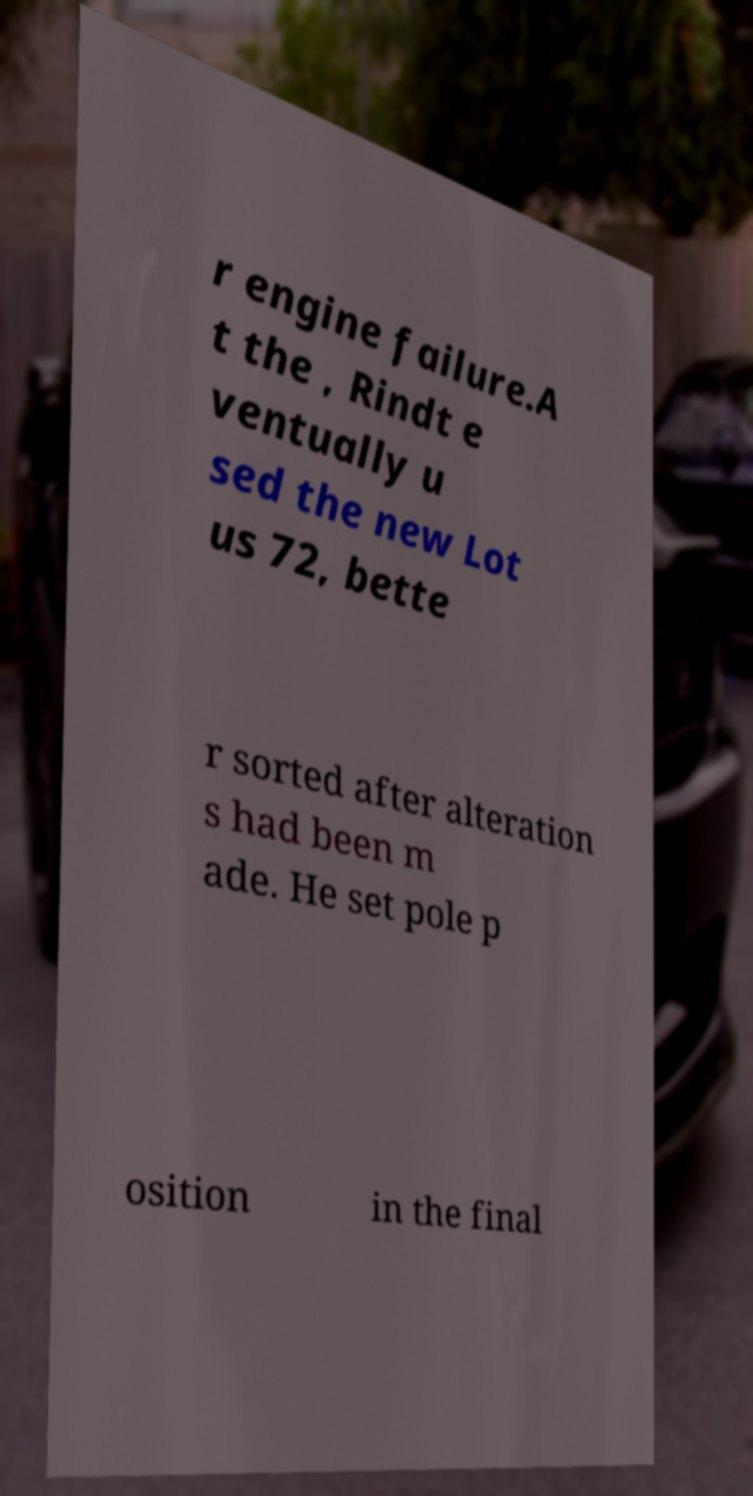Please read and relay the text visible in this image. What does it say? r engine failure.A t the , Rindt e ventually u sed the new Lot us 72, bette r sorted after alteration s had been m ade. He set pole p osition in the final 